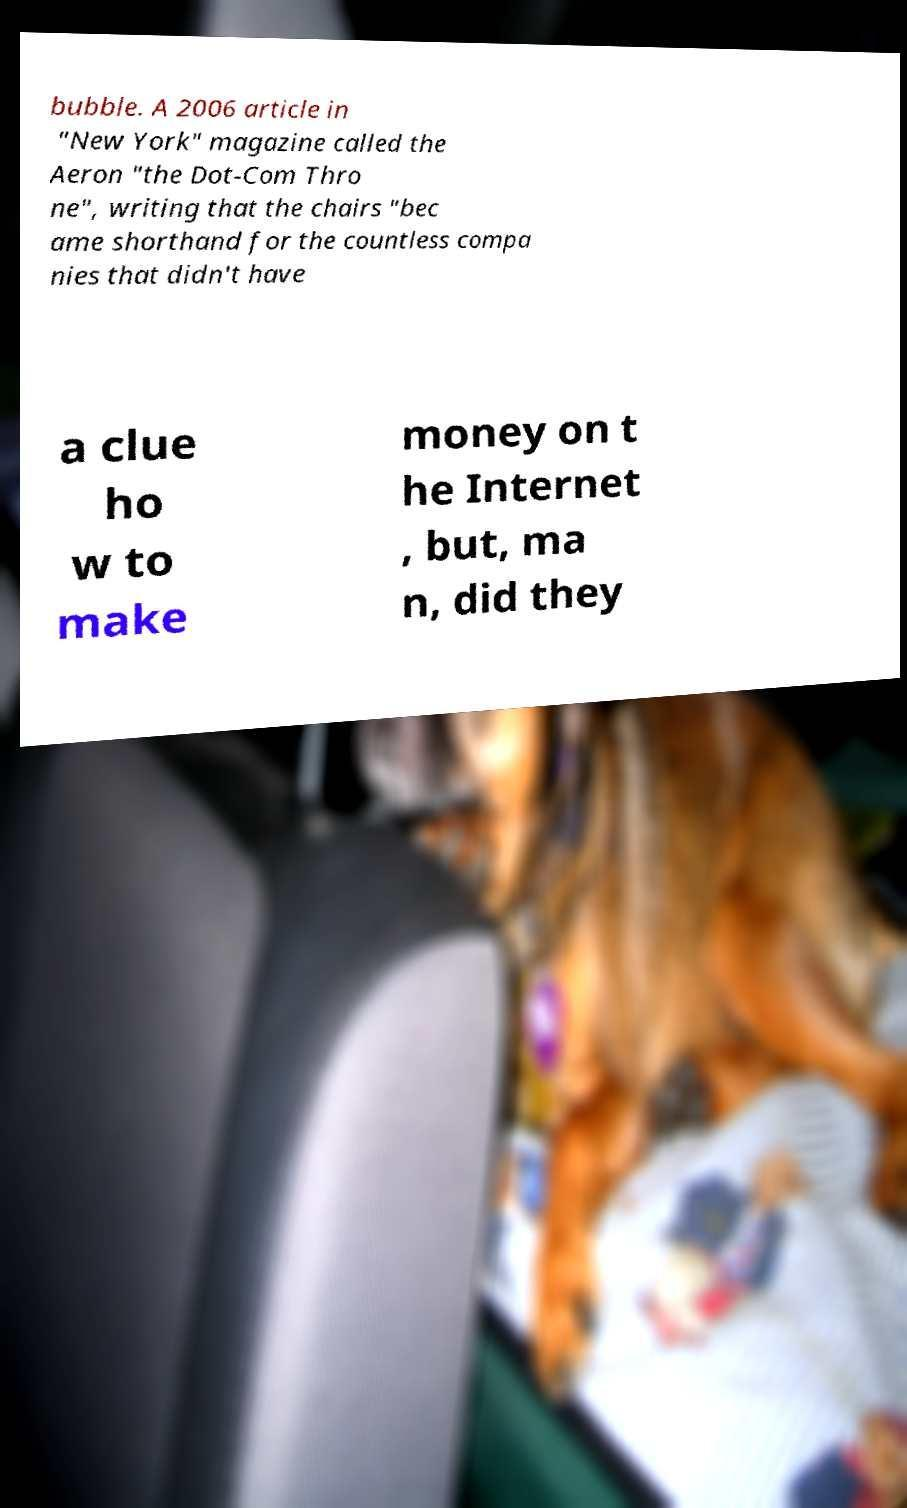Can you read and provide the text displayed in the image?This photo seems to have some interesting text. Can you extract and type it out for me? bubble. A 2006 article in "New York" magazine called the Aeron "the Dot-Com Thro ne", writing that the chairs "bec ame shorthand for the countless compa nies that didn't have a clue ho w to make money on t he Internet , but, ma n, did they 